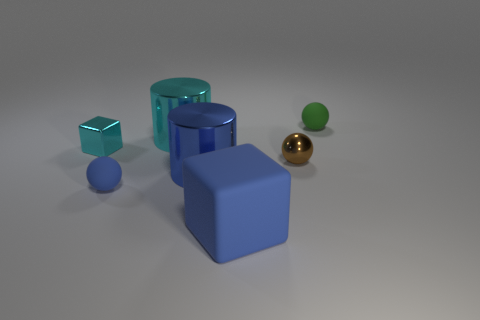What shape is the metal thing that is the same color as the big matte block?
Ensure brevity in your answer.  Cylinder. There is a metal cylinder that is on the right side of the large cyan metal cylinder; how big is it?
Offer a very short reply. Large. There is a cyan thing that is the same size as the blue rubber ball; what shape is it?
Your answer should be very brief. Cube. Does the large object in front of the blue metal cylinder have the same material as the cyan thing in front of the cyan metal cylinder?
Keep it short and to the point. No. The thing that is behind the cylinder that is behind the tiny block is made of what material?
Provide a succinct answer. Rubber. There is a thing in front of the matte ball on the left side of the rubber object to the right of the large blue cube; how big is it?
Provide a succinct answer. Large. Is the blue cylinder the same size as the blue block?
Your answer should be very brief. Yes. Does the matte object left of the big blue metal cylinder have the same shape as the small green rubber object that is behind the big rubber object?
Your answer should be very brief. Yes. Is there a small sphere left of the small rubber ball to the left of the large blue matte thing?
Your answer should be very brief. No. Is there a yellow rubber sphere?
Your answer should be very brief. No. 